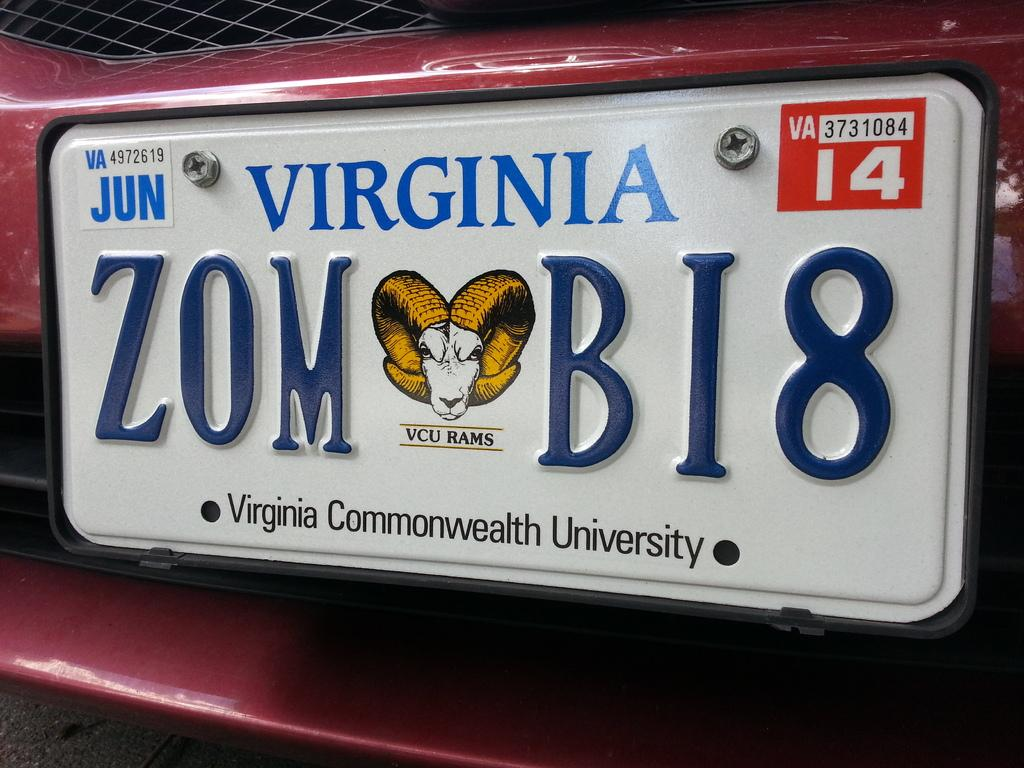<image>
Present a compact description of the photo's key features. A license plate that is from Virginia that says ZOMBI8. 